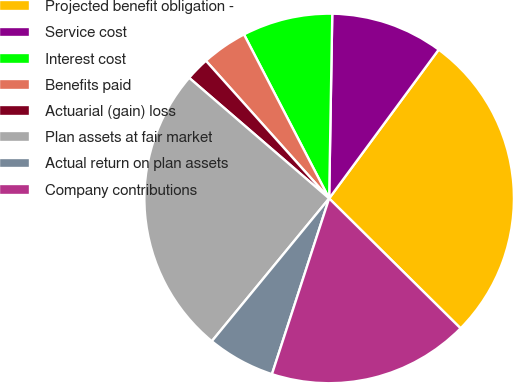Convert chart to OTSL. <chart><loc_0><loc_0><loc_500><loc_500><pie_chart><fcel>Projected benefit obligation -<fcel>Service cost<fcel>Interest cost<fcel>Benefits paid<fcel>Actuarial (gain) loss<fcel>Plan assets at fair market<fcel>Actual return on plan assets<fcel>Company contributions<nl><fcel>27.31%<fcel>9.83%<fcel>7.89%<fcel>4.0%<fcel>2.06%<fcel>25.37%<fcel>5.94%<fcel>17.6%<nl></chart> 